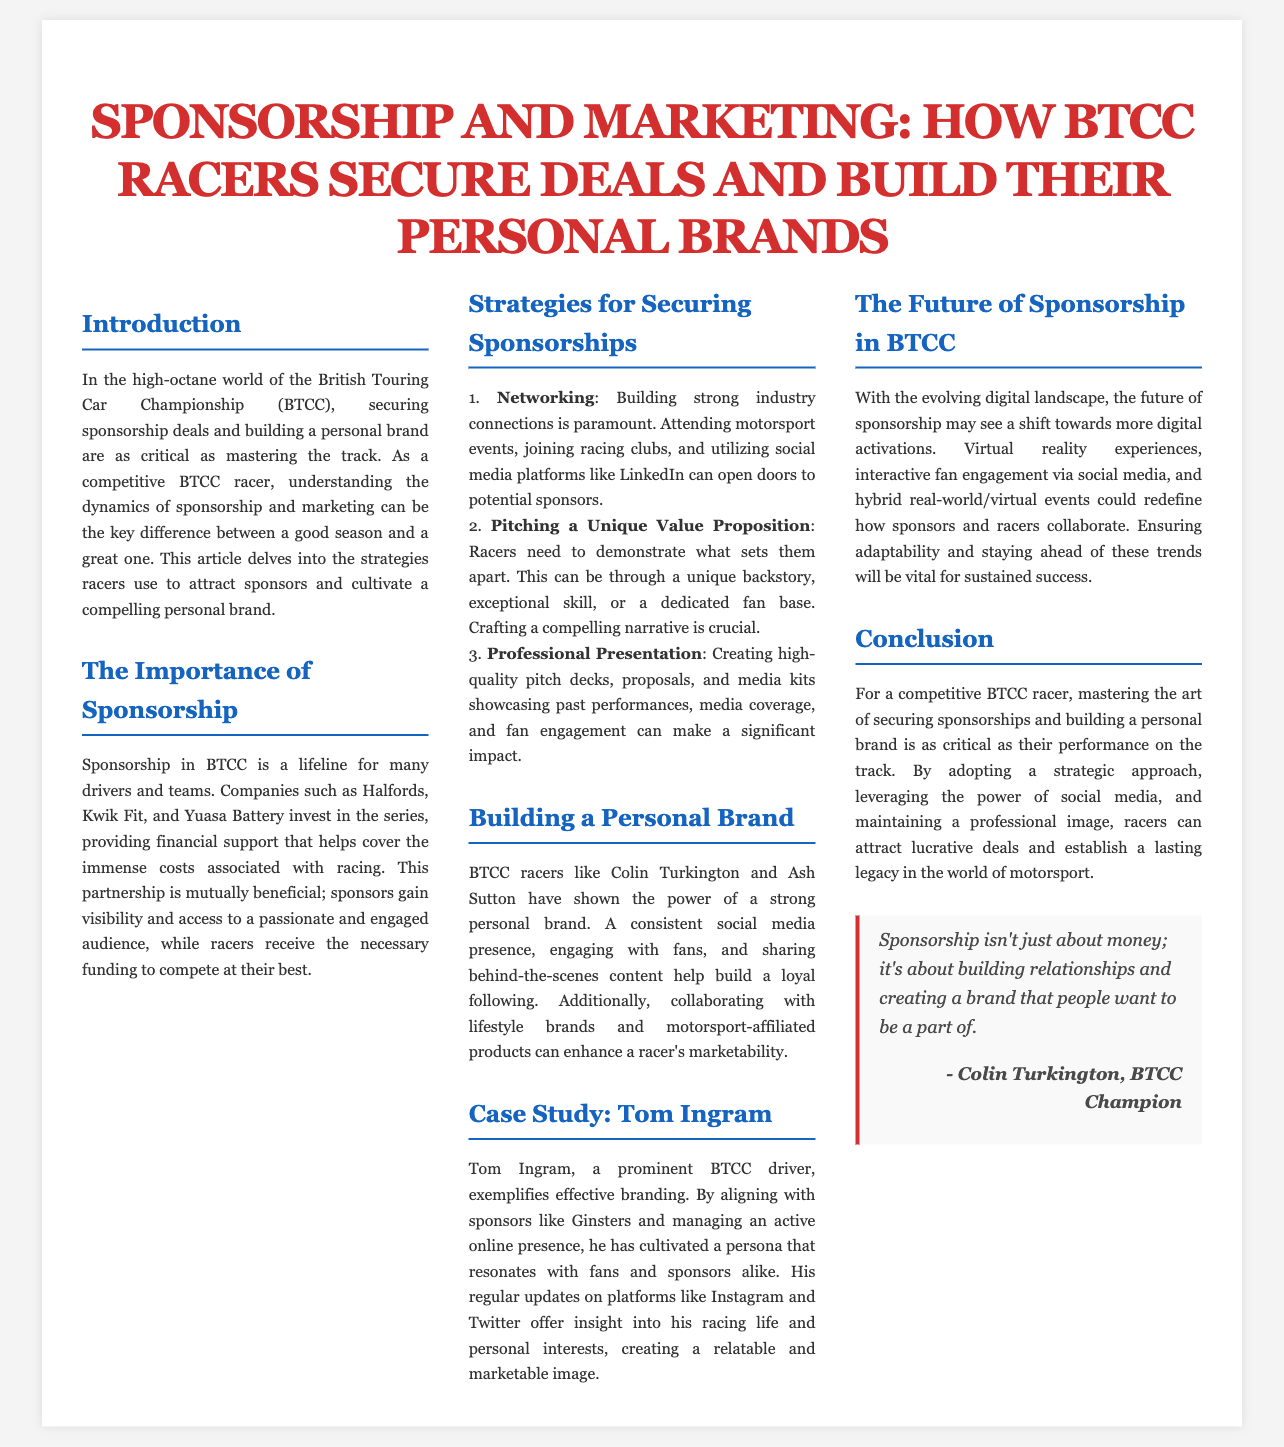What is the title of the article? The title is prominently displayed at the top of the document, highlighting the article's focus on sponsorship and marketing in BTCC.
Answer: Sponsorship and Marketing: How BTCC Racers Secure Deals and Build Their Personal Brands Who are some companies that sponsor BTCC? Companies involved in sponsorship are mentioned in the section about the importance of sponsorship, indicating their contribution to the sport.
Answer: Halfords, Kwik Fit, Yuasa Battery What is one strategy for securing sponsorships? The article lists multiple strategies for securing sponsorships, emphasizing the importance of networking among them.
Answer: Networking Which racer is used as a case study? The specific racer highlighted in the case study section is identified, showcasing their branding strategies and sponsorship success.
Answer: Tom Ingram What does Colin Turkington suggest is important in sponsorship? The quote from Colin Turkington summarizes his perspective on sponsorship, emphasizing relationship building over financial aspects.
Answer: Building relationships How does Tom Ingram maintain his marketability? The document describes Tom Ingram's active engagement on social media and his sponsorship alignments as key factors in his marketability.
Answer: Active online presence What is a potential future trend in BTCC sponsorship? The section discussing the future of sponsorship introduces various innovative strategies, indicating a shift towards digital engagement.
Answer: Digital activations 